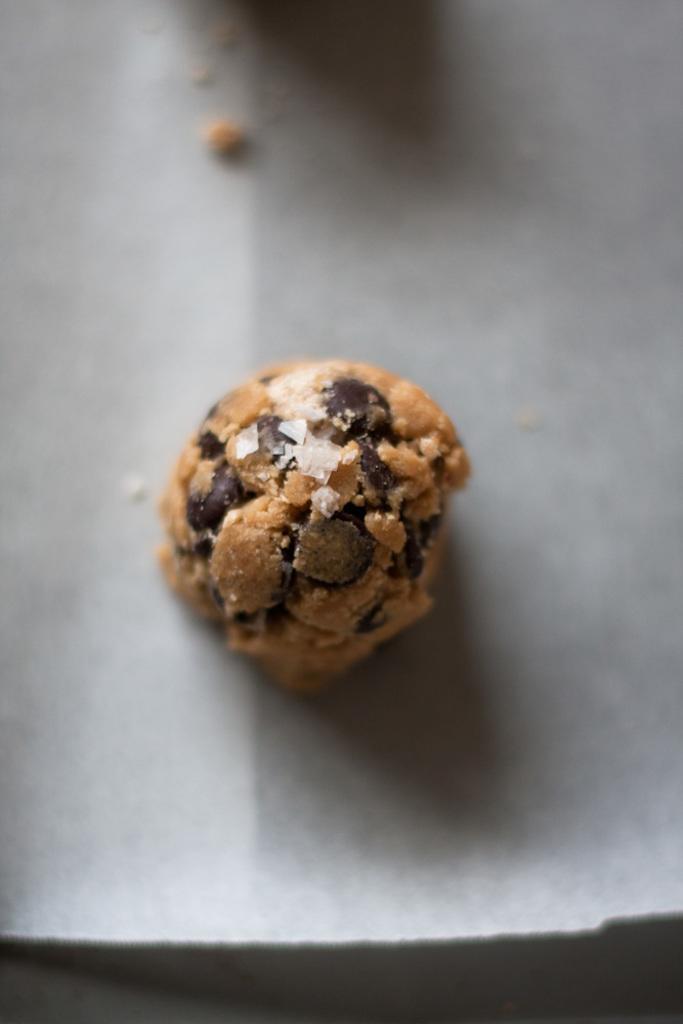Can you describe this image briefly? In this picture I can observe food. The food is in brown color. The food is placed on the grey color surface. 